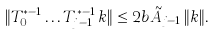<formula> <loc_0><loc_0><loc_500><loc_500>\| T _ { 0 } ^ { * - 1 } \dots T _ { j - 1 } ^ { * - 1 } \, k \| \leq 2 b \tilde { A } _ { j - 1 } \, \| k \| .</formula> 